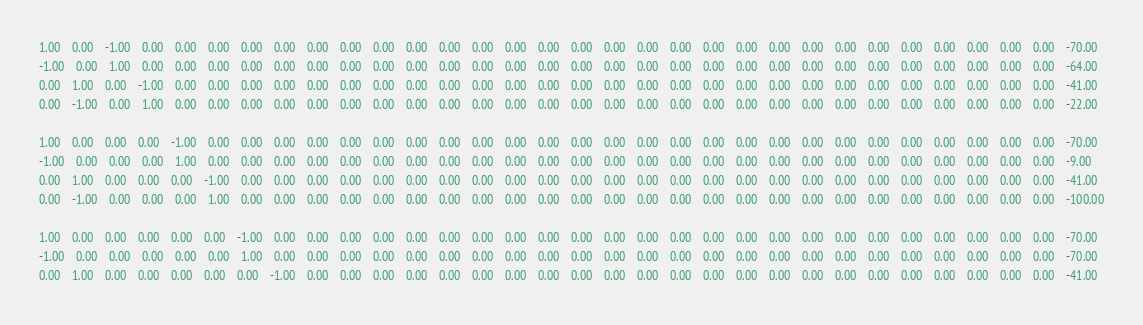<code> <loc_0><loc_0><loc_500><loc_500><_Matlab_>1.00	0.00	-1.00	0.00	0.00	0.00	0.00	0.00	0.00	0.00	0.00	0.00	0.00	0.00	0.00	0.00	0.00	0.00	0.00	0.00	0.00	0.00	0.00	0.00	0.00	0.00	0.00	0.00	0.00	0.00	0.00	-70.00
-1.00	0.00	1.00	0.00	0.00	0.00	0.00	0.00	0.00	0.00	0.00	0.00	0.00	0.00	0.00	0.00	0.00	0.00	0.00	0.00	0.00	0.00	0.00	0.00	0.00	0.00	0.00	0.00	0.00	0.00	0.00	-64.00
0.00	1.00	0.00	-1.00	0.00	0.00	0.00	0.00	0.00	0.00	0.00	0.00	0.00	0.00	0.00	0.00	0.00	0.00	0.00	0.00	0.00	0.00	0.00	0.00	0.00	0.00	0.00	0.00	0.00	0.00	0.00	-41.00
0.00	-1.00	0.00	1.00	0.00	0.00	0.00	0.00	0.00	0.00	0.00	0.00	0.00	0.00	0.00	0.00	0.00	0.00	0.00	0.00	0.00	0.00	0.00	0.00	0.00	0.00	0.00	0.00	0.00	0.00	0.00	-22.00

1.00	0.00	0.00	0.00	-1.00	0.00	0.00	0.00	0.00	0.00	0.00	0.00	0.00	0.00	0.00	0.00	0.00	0.00	0.00	0.00	0.00	0.00	0.00	0.00	0.00	0.00	0.00	0.00	0.00	0.00	0.00	-70.00
-1.00	0.00	0.00	0.00	1.00	0.00	0.00	0.00	0.00	0.00	0.00	0.00	0.00	0.00	0.00	0.00	0.00	0.00	0.00	0.00	0.00	0.00	0.00	0.00	0.00	0.00	0.00	0.00	0.00	0.00	0.00	-9.00
0.00	1.00	0.00	0.00	0.00	-1.00	0.00	0.00	0.00	0.00	0.00	0.00	0.00	0.00	0.00	0.00	0.00	0.00	0.00	0.00	0.00	0.00	0.00	0.00	0.00	0.00	0.00	0.00	0.00	0.00	0.00	-41.00
0.00	-1.00	0.00	0.00	0.00	1.00	0.00	0.00	0.00	0.00	0.00	0.00	0.00	0.00	0.00	0.00	0.00	0.00	0.00	0.00	0.00	0.00	0.00	0.00	0.00	0.00	0.00	0.00	0.00	0.00	0.00	-100.00

1.00	0.00	0.00	0.00	0.00	0.00	-1.00	0.00	0.00	0.00	0.00	0.00	0.00	0.00	0.00	0.00	0.00	0.00	0.00	0.00	0.00	0.00	0.00	0.00	0.00	0.00	0.00	0.00	0.00	0.00	0.00	-70.00
-1.00	0.00	0.00	0.00	0.00	0.00	1.00	0.00	0.00	0.00	0.00	0.00	0.00	0.00	0.00	0.00	0.00	0.00	0.00	0.00	0.00	0.00	0.00	0.00	0.00	0.00	0.00	0.00	0.00	0.00	0.00	-70.00
0.00	1.00	0.00	0.00	0.00	0.00	0.00	-1.00	0.00	0.00	0.00	0.00	0.00	0.00	0.00	0.00	0.00	0.00	0.00	0.00	0.00	0.00	0.00	0.00	0.00	0.00	0.00	0.00	0.00	0.00	0.00	-41.00</code> 